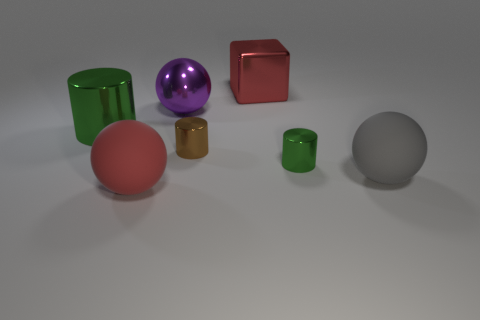The thing to the left of the big matte sphere that is to the left of the tiny brown metallic cylinder is made of what material?
Provide a short and direct response. Metal. Is the purple shiny sphere the same size as the red metal block?
Provide a succinct answer. Yes. What number of objects are big things that are to the right of the small green cylinder or large green rubber objects?
Give a very brief answer. 1. What shape is the green metal object that is right of the red object that is behind the tiny green metal cylinder?
Offer a very short reply. Cylinder. There is a brown shiny object; is it the same size as the green metallic cylinder on the right side of the purple metallic thing?
Keep it short and to the point. Yes. There is a sphere that is behind the brown metal thing; what is it made of?
Offer a terse response. Metal. What number of large red things are in front of the large gray rubber object and behind the large gray rubber sphere?
Offer a very short reply. 0. There is a green object that is the same size as the cube; what is it made of?
Your response must be concise. Metal. Is the size of the green thing behind the small brown object the same as the object that is in front of the gray ball?
Give a very brief answer. Yes. There is a big purple thing; are there any green objects to the right of it?
Your answer should be very brief. Yes. 